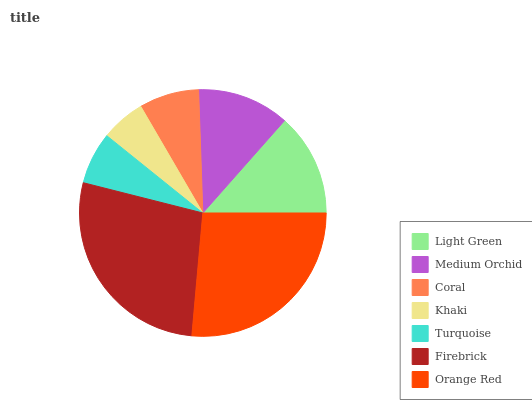Is Khaki the minimum?
Answer yes or no. Yes. Is Firebrick the maximum?
Answer yes or no. Yes. Is Medium Orchid the minimum?
Answer yes or no. No. Is Medium Orchid the maximum?
Answer yes or no. No. Is Light Green greater than Medium Orchid?
Answer yes or no. Yes. Is Medium Orchid less than Light Green?
Answer yes or no. Yes. Is Medium Orchid greater than Light Green?
Answer yes or no. No. Is Light Green less than Medium Orchid?
Answer yes or no. No. Is Medium Orchid the high median?
Answer yes or no. Yes. Is Medium Orchid the low median?
Answer yes or no. Yes. Is Orange Red the high median?
Answer yes or no. No. Is Orange Red the low median?
Answer yes or no. No. 